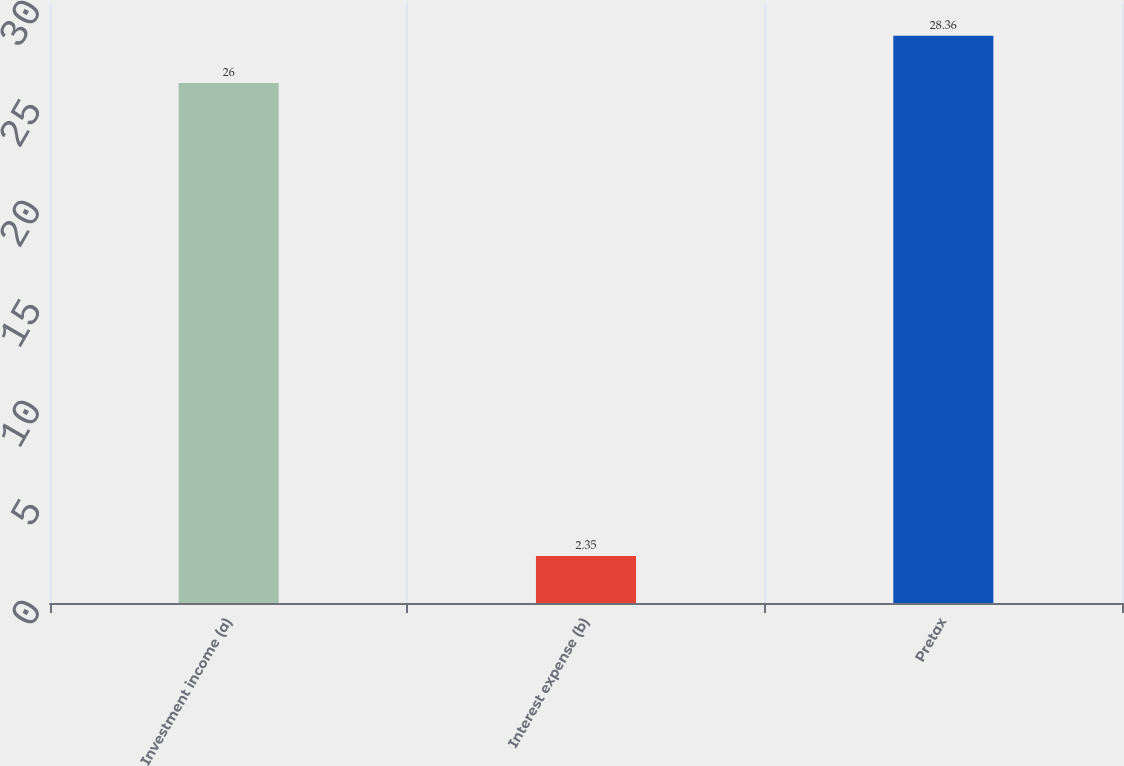Convert chart to OTSL. <chart><loc_0><loc_0><loc_500><loc_500><bar_chart><fcel>Investment income (a)<fcel>Interest expense (b)<fcel>Pretax<nl><fcel>26<fcel>2.35<fcel>28.36<nl></chart> 